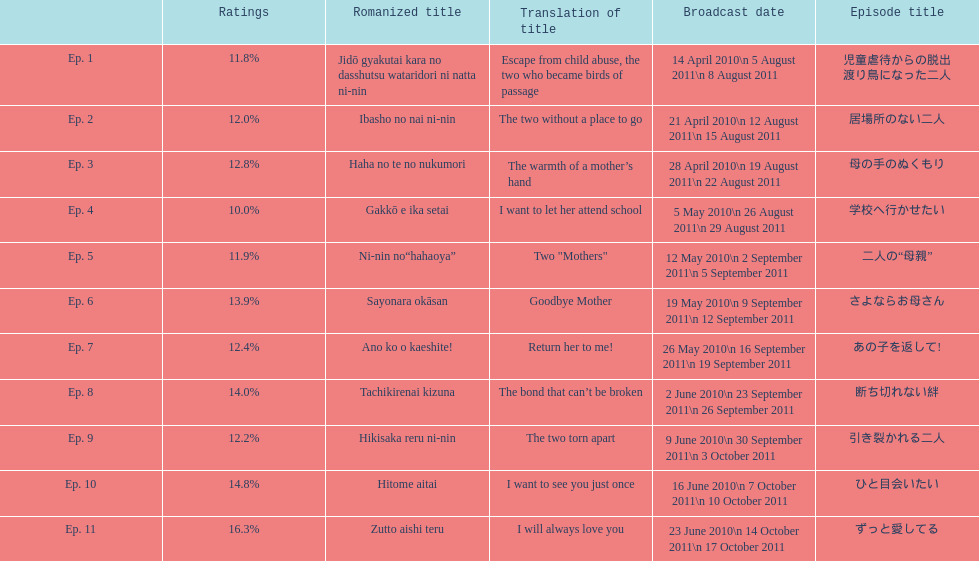What as the percentage total of ratings for episode 8? 14.0%. Could you help me parse every detail presented in this table? {'header': ['', 'Ratings', 'Romanized title', 'Translation of title', 'Broadcast date', 'Episode title'], 'rows': [['Ep. 1', '11.8%', 'Jidō gyakutai kara no dasshutsu wataridori ni natta ni-nin', 'Escape from child abuse, the two who became birds of passage', '14 April 2010\\n 5 August 2011\\n 8 August 2011', '児童虐待からの脱出 渡り鳥になった二人'], ['Ep. 2', '12.0%', 'Ibasho no nai ni-nin', 'The two without a place to go', '21 April 2010\\n 12 August 2011\\n 15 August 2011', '居場所のない二人'], ['Ep. 3', '12.8%', 'Haha no te no nukumori', 'The warmth of a mother’s hand', '28 April 2010\\n 19 August 2011\\n 22 August 2011', '母の手のぬくもり'], ['Ep. 4', '10.0%', 'Gakkō e ika setai', 'I want to let her attend school', '5 May 2010\\n 26 August 2011\\n 29 August 2011', '学校へ行かせたい'], ['Ep. 5', '11.9%', 'Ni-nin no“hahaoya”', 'Two "Mothers"', '12 May 2010\\n 2 September 2011\\n 5 September 2011', '二人の“母親”'], ['Ep. 6', '13.9%', 'Sayonara okāsan', 'Goodbye Mother', '19 May 2010\\n 9 September 2011\\n 12 September 2011', 'さよならお母さん'], ['Ep. 7', '12.4%', 'Ano ko o kaeshite!', 'Return her to me!', '26 May 2010\\n 16 September 2011\\n 19 September 2011', 'あの子を返して!'], ['Ep. 8', '14.0%', 'Tachikirenai kizuna', 'The bond that can’t be broken', '2 June 2010\\n 23 September 2011\\n 26 September 2011', '断ち切れない絆'], ['Ep. 9', '12.2%', 'Hikisaka reru ni-nin', 'The two torn apart', '9 June 2010\\n 30 September 2011\\n 3 October 2011', '引き裂かれる二人'], ['Ep. 10', '14.8%', 'Hitome aitai', 'I want to see you just once', '16 June 2010\\n 7 October 2011\\n 10 October 2011', 'ひと目会いたい'], ['Ep. 11', '16.3%', 'Zutto aishi teru', 'I will always love you', '23 June 2010\\n 14 October 2011\\n 17 October 2011', 'ずっと愛してる']]} 